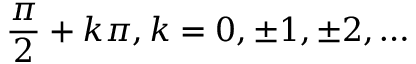<formula> <loc_0><loc_0><loc_500><loc_500>{ \frac { \pi } { 2 } } + k \pi , k = 0 , \pm 1 , \pm 2 , \dots</formula> 